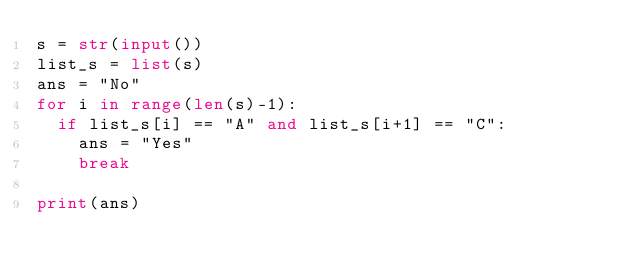Convert code to text. <code><loc_0><loc_0><loc_500><loc_500><_Python_>s = str(input())
list_s = list(s)
ans = "No"
for i in range(len(s)-1):
	if list_s[i] == "A" and list_s[i+1] == "C":
		ans = "Yes"
		break

print(ans)</code> 